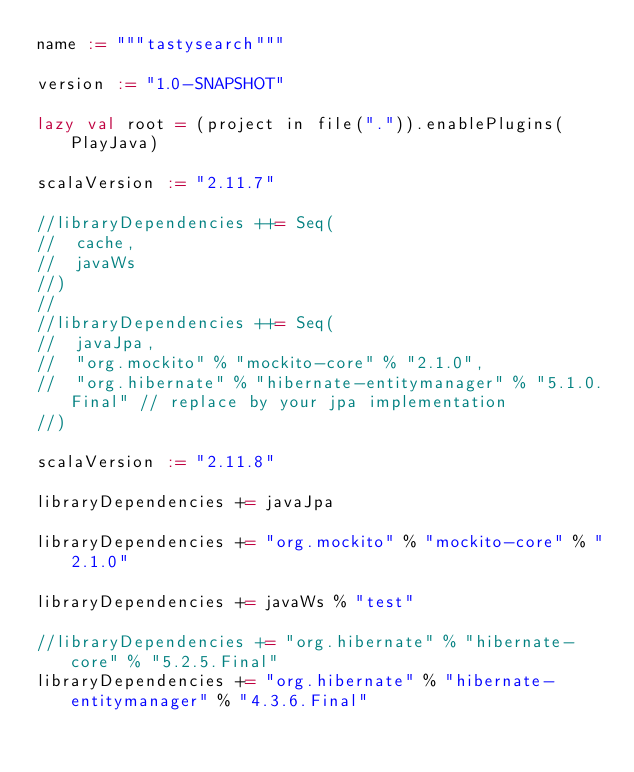<code> <loc_0><loc_0><loc_500><loc_500><_Scala_>name := """tastysearch"""

version := "1.0-SNAPSHOT"

lazy val root = (project in file(".")).enablePlugins(PlayJava)

scalaVersion := "2.11.7"

//libraryDependencies ++= Seq(
//  cache,
//  javaWs
//)
//
//libraryDependencies ++= Seq(
//  javaJpa,
//  "org.mockito" % "mockito-core" % "2.1.0",
//  "org.hibernate" % "hibernate-entitymanager" % "5.1.0.Final" // replace by your jpa implementation
//)

scalaVersion := "2.11.8"

libraryDependencies += javaJpa

libraryDependencies += "org.mockito" % "mockito-core" % "2.1.0"

libraryDependencies += javaWs % "test"

//libraryDependencies += "org.hibernate" % "hibernate-core" % "5.2.5.Final"
libraryDependencies += "org.hibernate" % "hibernate-entitymanager" % "4.3.6.Final"

</code> 